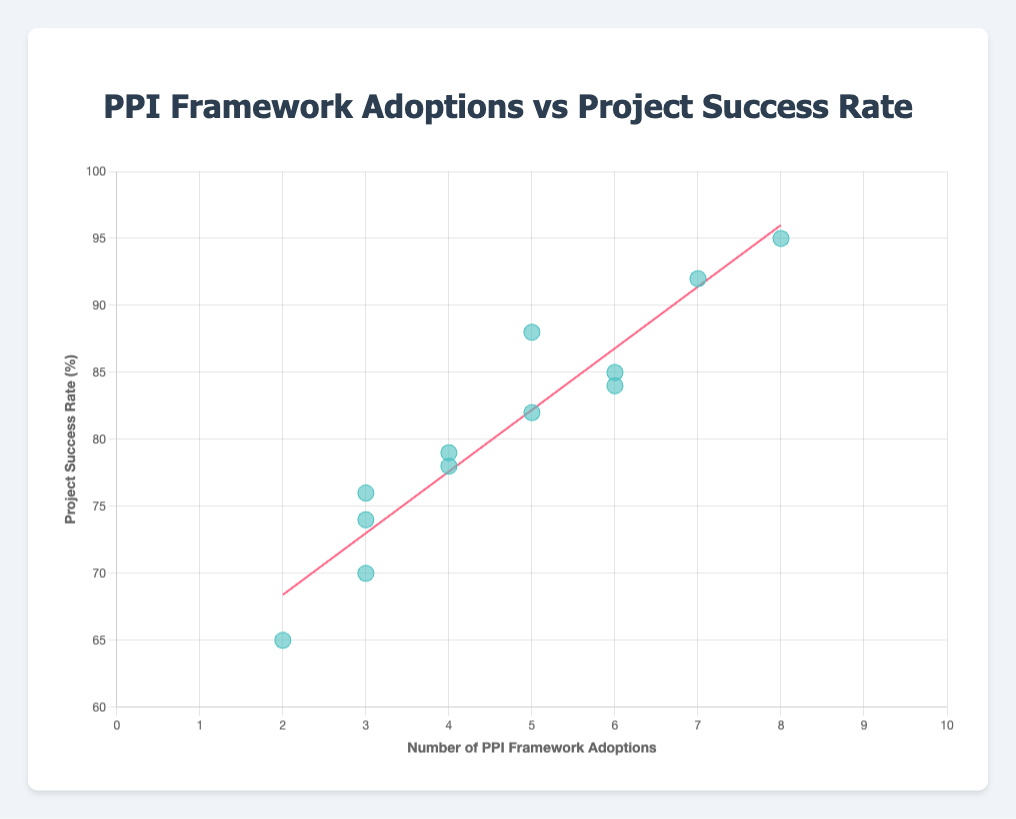What is the title of the chart? The title is usually found at the top of the chart. In this case, it reads: "PPI Framework Adoptions vs Project Success Rate".
Answer: PPI Framework Adoptions vs Project Success Rate What are the labels of the x and y axes? The x-axis label is "Number of PPI Framework Adoptions," and the y-axis label is "Project Success Rate (%)". These labels provide context for the data being visually represented.
Answer: Number of PPI Framework Adoptions; Project Success Rate (%) How many data points are there in the scatter plot? Count the number of distinct points shown in the scatter plot. Each point represents an industry with its corresponding number of PPI adoptions and success rate. The data provided lists 12 industries.
Answer: 12 Which industry has the highest project success rate and what is it? Identify the point on the scatter plot that is highest on the y-axis. The given data shows that "Automotive" has the highest success rate of 95%.
Answer: Automotive; 95% What is the trend indicated by the trend line? A trend line shows the general direction of the data points. In this scatter plot, the trend line should indicate whether an increase in PPI adoptions correlates with an increase in project success rate. Given the data, the line appears to have a positive slope.
Answer: Positive correlation Which industry has the least number of PPI adoptions and what is its project success rate? Identify the point on the scatter plot furthest left on the x-axis. According to the data, "Retail" has the fewest PPI adoptions (2) with a success rate of 65%.
Answer: Retail; 65% Calculate the average number of PPI adoptions across all industries. Sum up the number of PPI adoptions for all industries and divide by the total number of industries: (5+3+7+2+6+4+3+8+5+4+6+3) / 12 = 56 / 12 = 4.67.
Answer: 4.67 Which industry shows the highest deviation from the trend line? Deviation from the trend line can be judged by visual estimation of the distance of a point from the trend line. The "Automotive" industry appears to be the most above the trend line due to its exceptionally high success rate.
Answer: Automotive Is there any industry where increasing the number of PPI adoptions does not result in a high project success rate? Look for data points that do not follow the general trend of increasing success rates with more PPI adoptions. "Public Sector" has 3 PPI adoptions but a relatively low success rate of 70%.
Answer: Public Sector; 70% What can be inferred about the relationship between the number of PPI adoptions and project success rate? Based on the positive slope of the trend line and the clustering of the data points, it can be inferred that generally, more PPI adoptions are associated with higher project success rates.
Answer: Positive correlation 